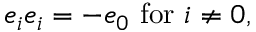Convert formula to latex. <formula><loc_0><loc_0><loc_500><loc_500>e _ { i } e _ { i } = - e _ { 0 } \, { f o r } \, i \neq 0 ,</formula> 